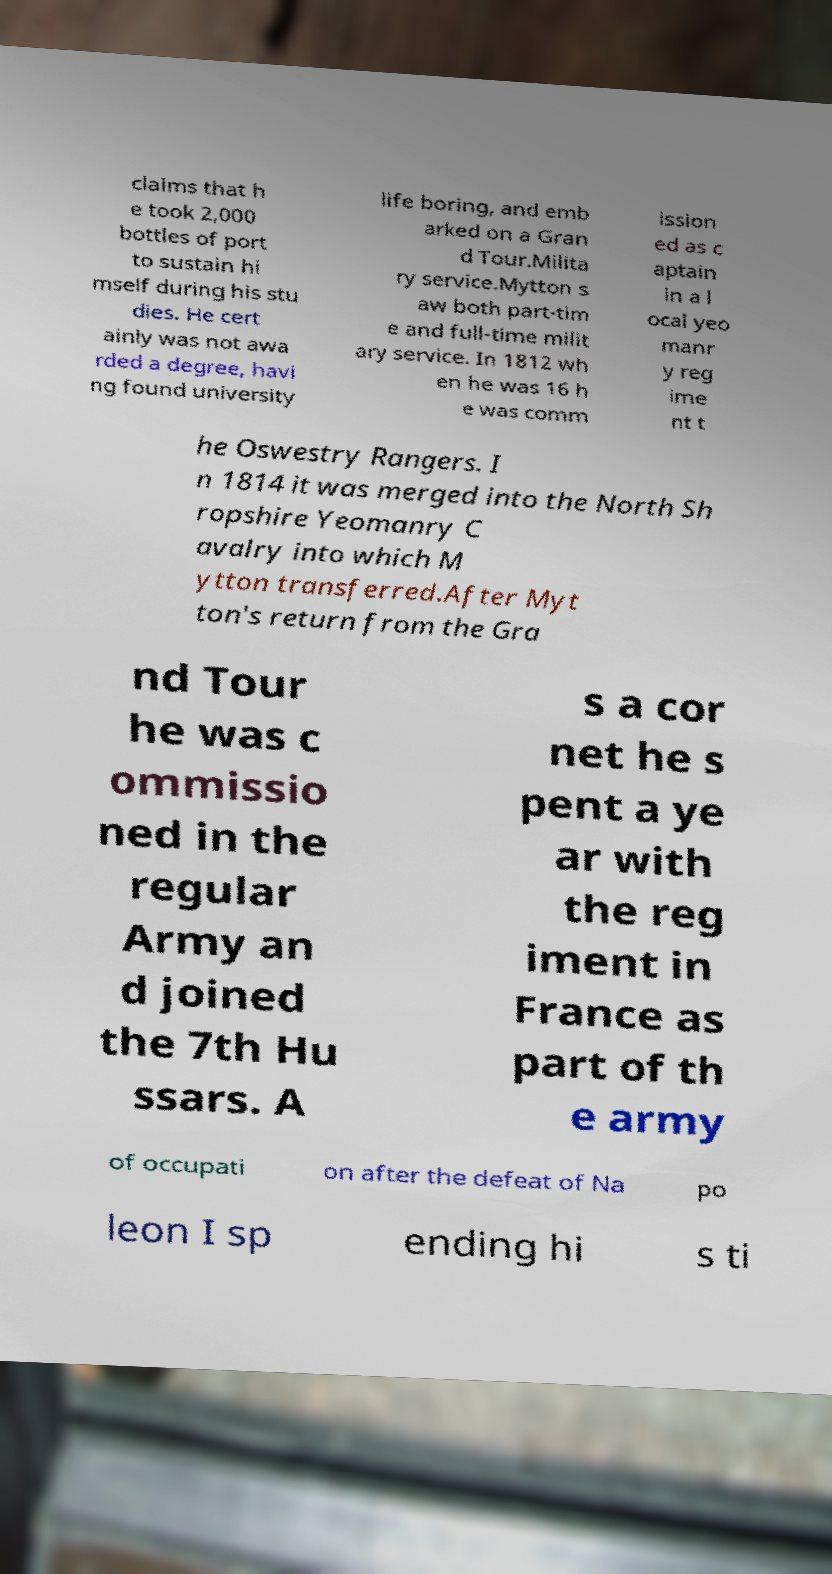There's text embedded in this image that I need extracted. Can you transcribe it verbatim? claims that h e took 2,000 bottles of port to sustain hi mself during his stu dies. He cert ainly was not awa rded a degree, havi ng found university life boring, and emb arked on a Gran d Tour.Milita ry service.Mytton s aw both part-tim e and full-time milit ary service. In 1812 wh en he was 16 h e was comm ission ed as c aptain in a l ocal yeo manr y reg ime nt t he Oswestry Rangers. I n 1814 it was merged into the North Sh ropshire Yeomanry C avalry into which M ytton transferred.After Myt ton's return from the Gra nd Tour he was c ommissio ned in the regular Army an d joined the 7th Hu ssars. A s a cor net he s pent a ye ar with the reg iment in France as part of th e army of occupati on after the defeat of Na po leon I sp ending hi s ti 